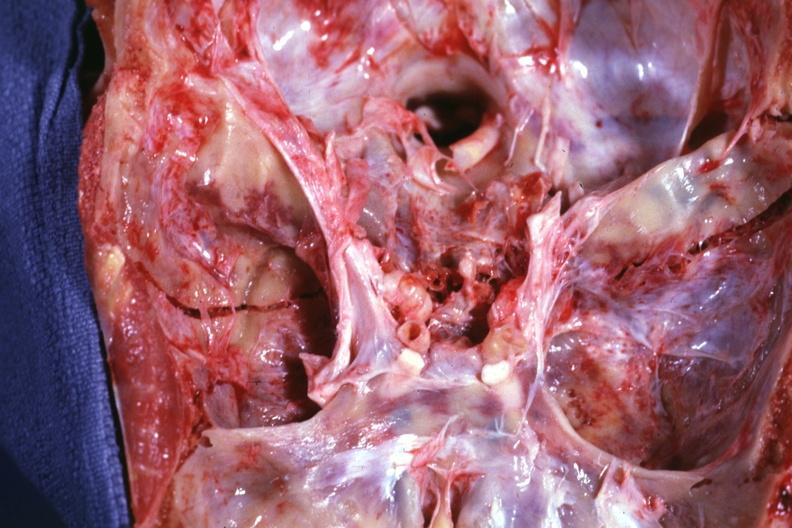what is present?
Answer the question using a single word or phrase. Basal skull fracture 